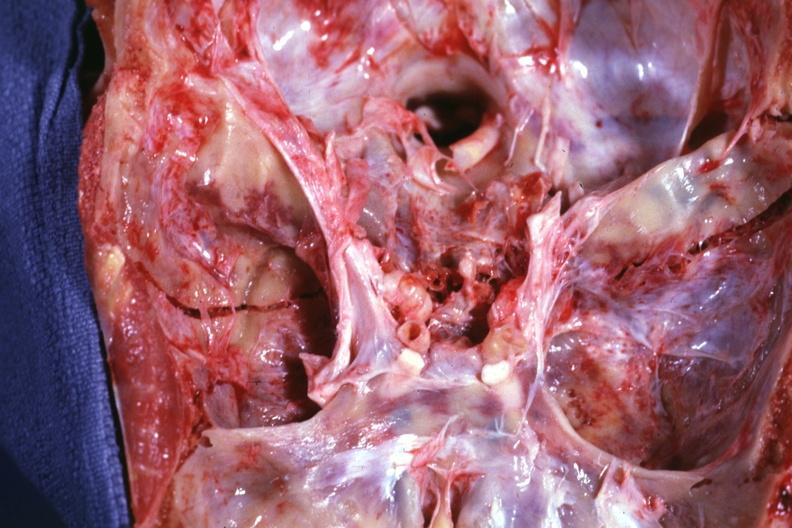what is present?
Answer the question using a single word or phrase. Basal skull fracture 